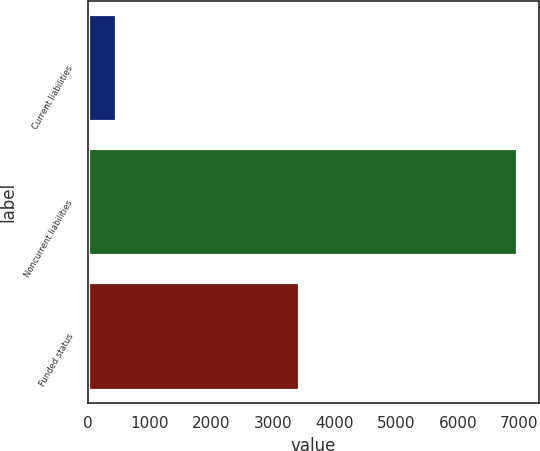Convert chart to OTSL. <chart><loc_0><loc_0><loc_500><loc_500><bar_chart><fcel>Current liabilities<fcel>Noncurrent liabilities<fcel>Funded status<nl><fcel>459<fcel>6970<fcel>3424<nl></chart> 